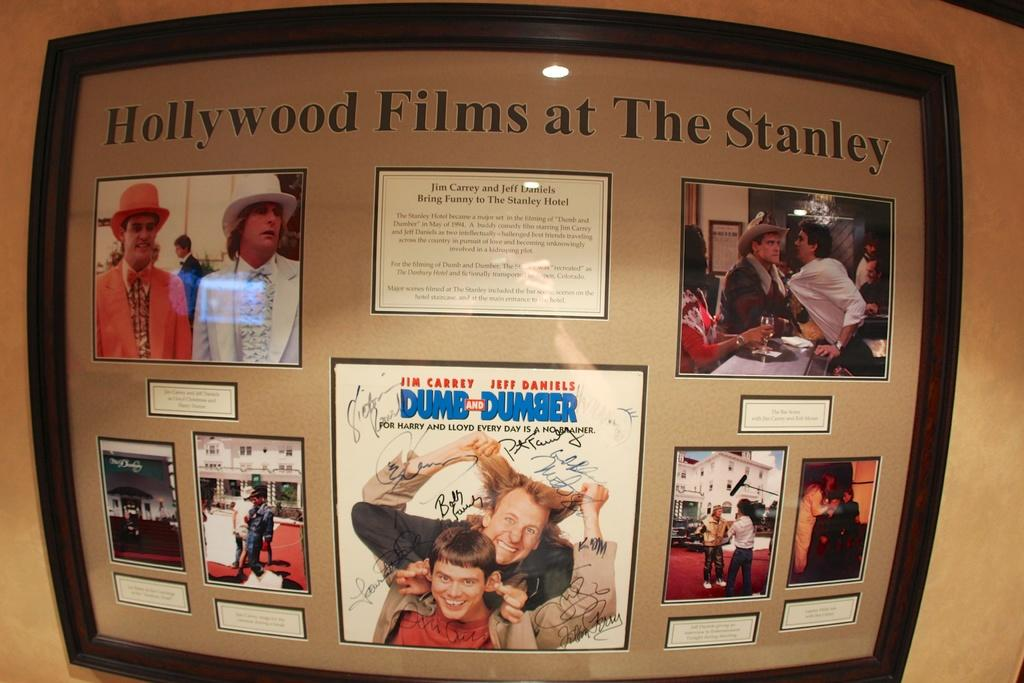Provide a one-sentence caption for the provided image. A framed display titled Hollywood Films at The Stanley. 